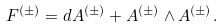Convert formula to latex. <formula><loc_0><loc_0><loc_500><loc_500>F ^ { ( \pm ) } = d A ^ { ( \pm ) } + A ^ { ( \pm ) } \wedge A ^ { ( \pm ) } .</formula> 